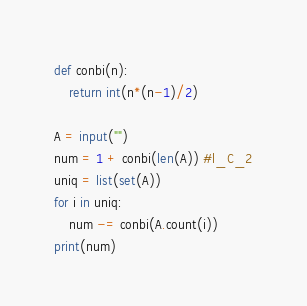Convert code to text. <code><loc_0><loc_0><loc_500><loc_500><_Python_>def conbi(n):
	return int(n*(n-1)/2)

A = input("")
num = 1 + conbi(len(A)) #l_C_2
uniq = list(set(A))
for i in uniq:
	num -= conbi(A.count(i))
print(num)
</code> 